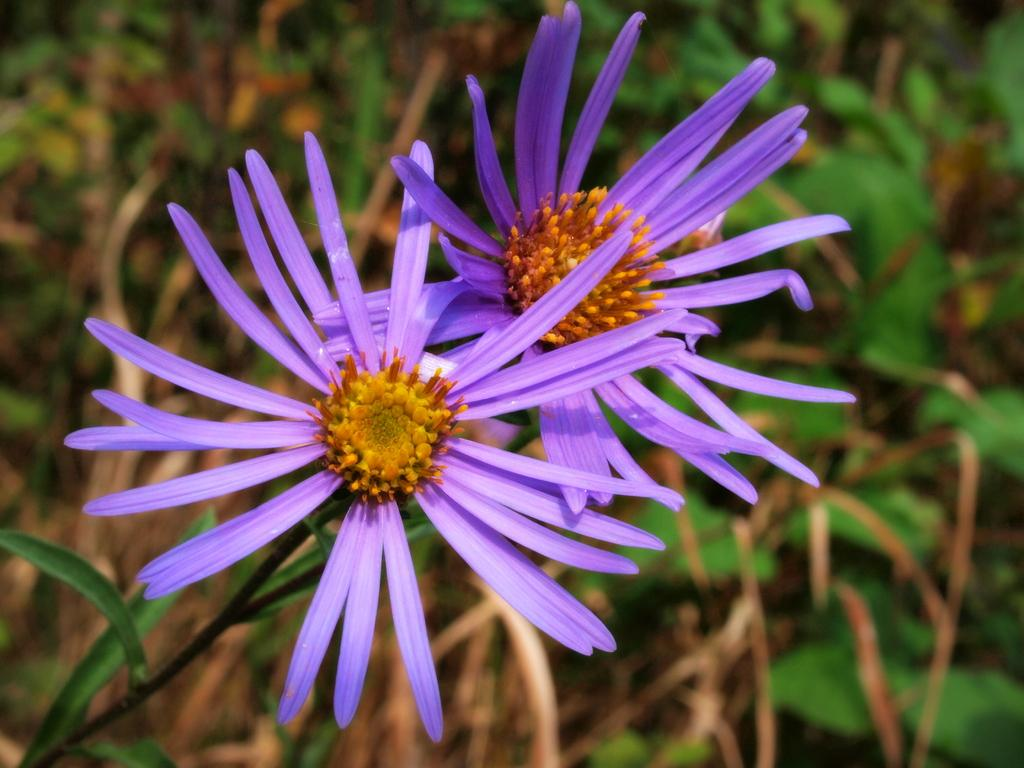What type of flowers can be seen in the image? There are two violet color flowers in the image. What other plant elements can be seen in the background of the image? Leaves and stems are visible in the background of the image. What type of advice can be seen written on the flowers in the image? There is no advice written on the flowers in the image; it only contains the flowers and plant elements. 